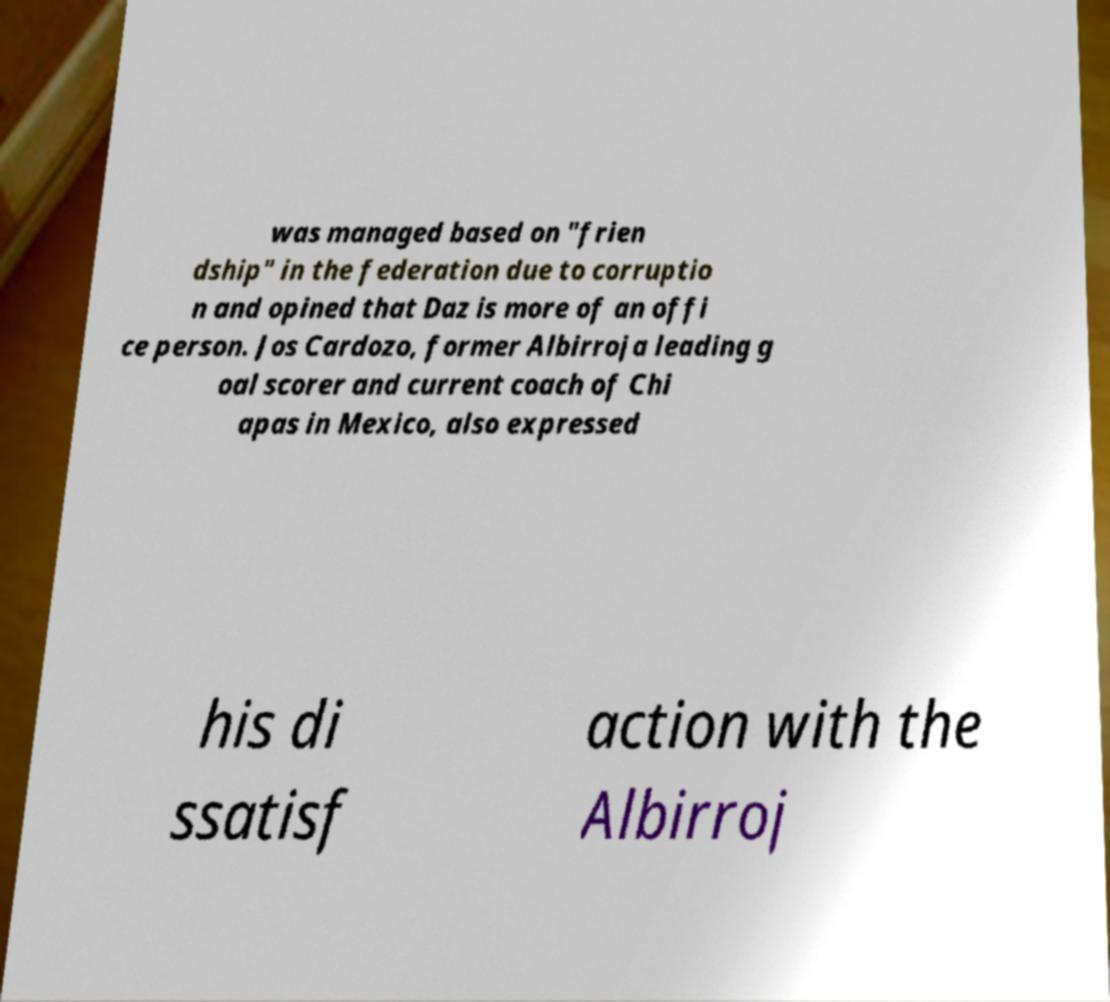I need the written content from this picture converted into text. Can you do that? was managed based on "frien dship" in the federation due to corruptio n and opined that Daz is more of an offi ce person. Jos Cardozo, former Albirroja leading g oal scorer and current coach of Chi apas in Mexico, also expressed his di ssatisf action with the Albirroj 